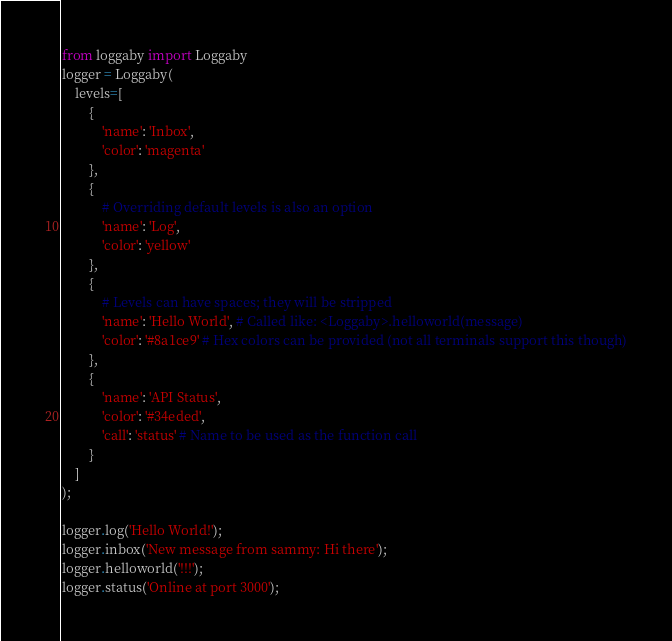<code> <loc_0><loc_0><loc_500><loc_500><_Python_>from loggaby import Loggaby
logger = Loggaby(
	levels=[
		{
			'name': 'Inbox',
			'color': 'magenta'
		},
		{
			# Overriding default levels is also an option
			'name': 'Log',
			'color': 'yellow'
		},
		{
			# Levels can have spaces; they will be stripped
			'name': 'Hello World', # Called like: <Loggaby>.helloworld(message)
			'color': '#8a1ce9' # Hex colors can be provided (not all terminals support this though)
		},
		{
			'name': 'API Status',
			'color': '#34eded',
			'call': 'status' # Name to be used as the function call
		}
	]
);

logger.log('Hello World!');
logger.inbox('New message from sammy: Hi there');
logger.helloworld('!!!');
logger.status('Online at port 3000');
</code> 